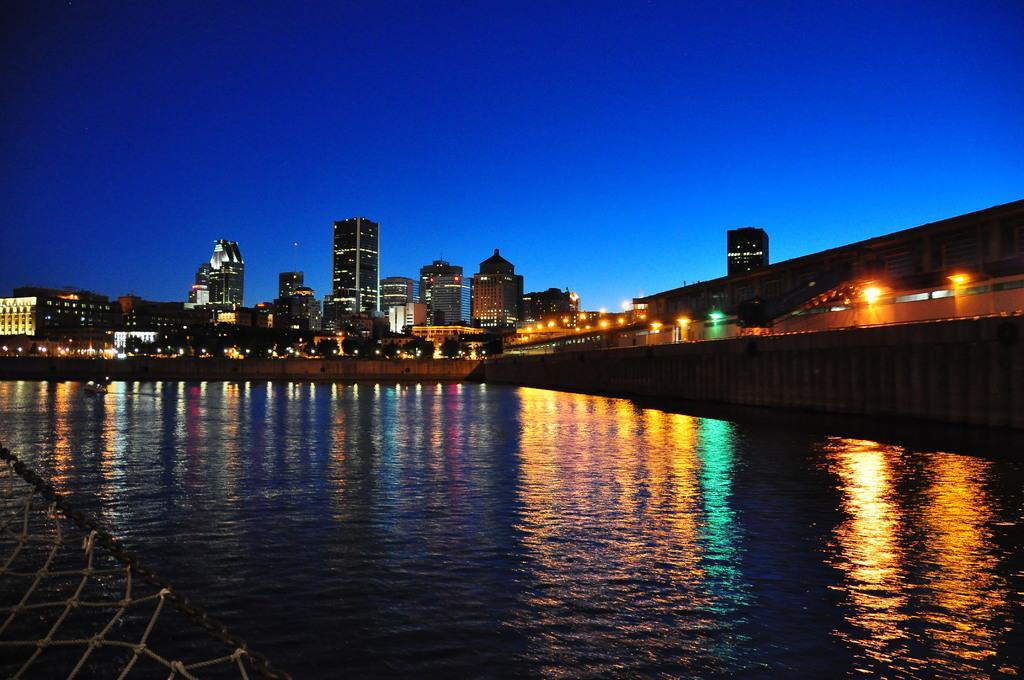What is the primary element present in the image? There is water in the image. What type of structures can be seen in the image? There are multiple buildings in the image. What can be seen illuminating the scene in the image? Lights are visible in the image. What part of the natural environment is visible in the image? The sky is visible in the image. How would you describe the overall lighting in the image? The image appears to be slightly dark. What design is being discussed at the meeting in the image? There is no meeting present in the image, so it is not possible to discuss any designs. 